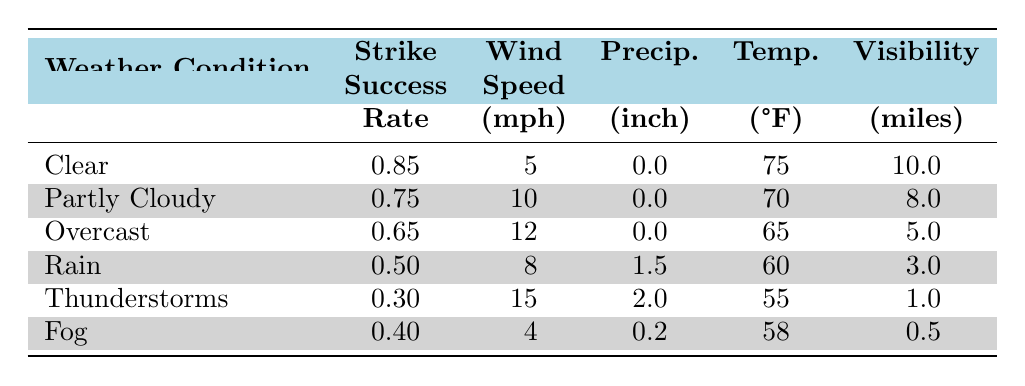What is the strike success rate in clear weather conditions? The table lists the weather condition "Clear" with a corresponding strike success rate of 0.85.
Answer: 0.85 What is the average wind speed during thunderstorms? The table provides the wind speed under the weather condition "Thunderstorms" as 15 mph.
Answer: 15 mph Is the strike success rate higher in partly cloudy conditions compared to overcast conditions? The success rate for "Partly Cloudy" is 0.75 and for "Overcast" it’s 0.65. Since 0.75 is greater than 0.65, the statement is true.
Answer: Yes What is the difference in strike success rate between rain and fog conditions? The success rate for "Rain" is 0.50 and for "Fog" it is 0.40. The difference can be calculated as 0.50 - 0.40 = 0.10.
Answer: 0.10 Which weather condition has the lowest visibility, and what is that value? The table shows "Fog" has the lowest visibility at 0.5 miles, which is less than other conditions listed.
Answer: Fog, 0.5 miles What is the average strike success rate across all weather conditions? The success rates are: 0.85, 0.75, 0.65, 0.50, 0.30, and 0.40. Summing them gives 3.45, and dividing by 6 yields an average of 3.45/6 = 0.575.
Answer: 0.575 Is there any weather condition where the visibility is greater than 10 miles? The table indicates no weather condition has visibility exceeding 10 miles, as the highest visibility recorded is 10 miles under "Clear".
Answer: No In which condition do we see the highest recorded precipitation, and what is that amount? The table shows "Thunderstorms" with a precipitation of 2.0 inches as the highest value.
Answer: Thunderstorms, 2.0 inches What relationship exists between average wind speed and strike success rate? By observing the table, a trend appears where higher average wind speeds correlate with lower success rates, with clear conditions having the lowest wind speed and highest success rate.
Answer: Negative correlation 